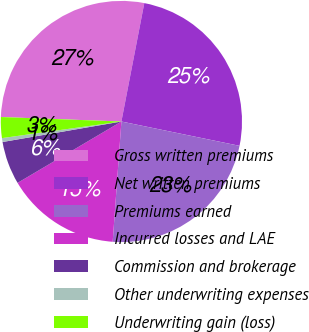Convert chart to OTSL. <chart><loc_0><loc_0><loc_500><loc_500><pie_chart><fcel>Gross written premiums<fcel>Net written premiums<fcel>Premiums earned<fcel>Incurred losses and LAE<fcel>Commission and brokerage<fcel>Other underwriting expenses<fcel>Underwriting gain (loss)<nl><fcel>27.45%<fcel>25.19%<fcel>22.92%<fcel>15.35%<fcel>5.78%<fcel>0.52%<fcel>2.79%<nl></chart> 